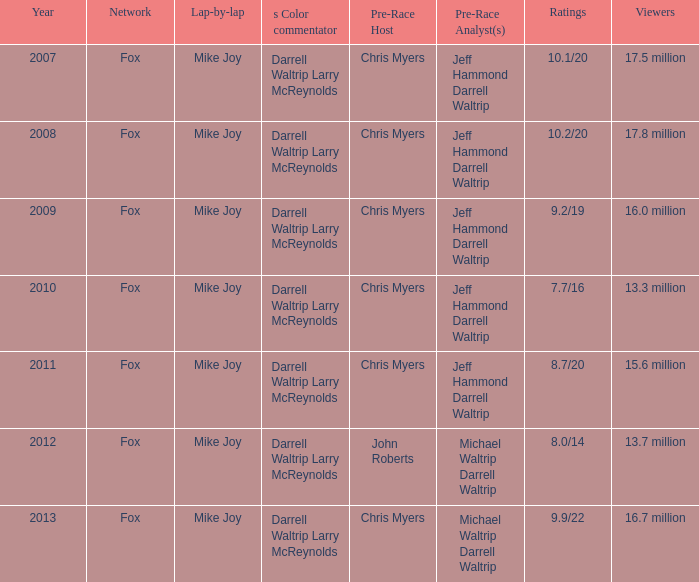What lap-by-lap features chris myers as the pre-race host, a year greater than 2008, and Mike Joy. 